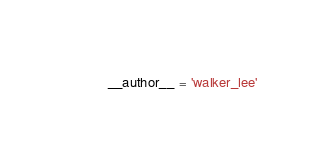Convert code to text. <code><loc_0><loc_0><loc_500><loc_500><_Python_>__author__ = 'walker_lee'</code> 